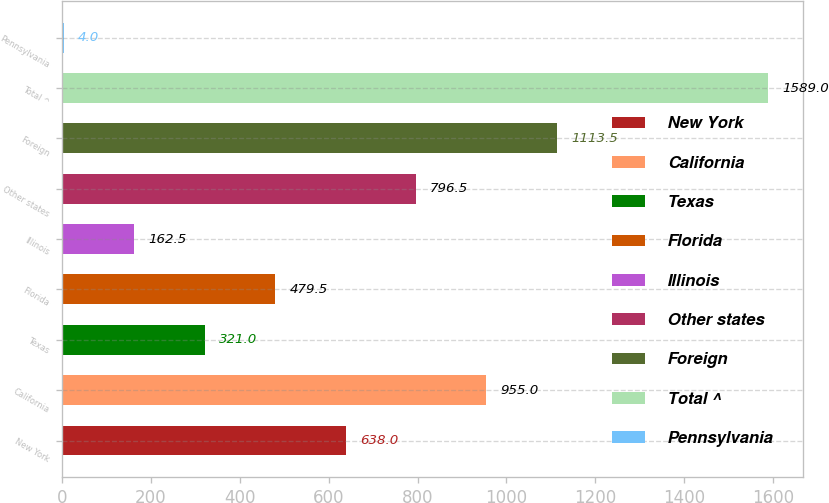Convert chart to OTSL. <chart><loc_0><loc_0><loc_500><loc_500><bar_chart><fcel>New York<fcel>California<fcel>Texas<fcel>Florida<fcel>Illinois<fcel>Other states<fcel>Foreign<fcel>Total ^<fcel>Pennsylvania<nl><fcel>638<fcel>955<fcel>321<fcel>479.5<fcel>162.5<fcel>796.5<fcel>1113.5<fcel>1589<fcel>4<nl></chart> 